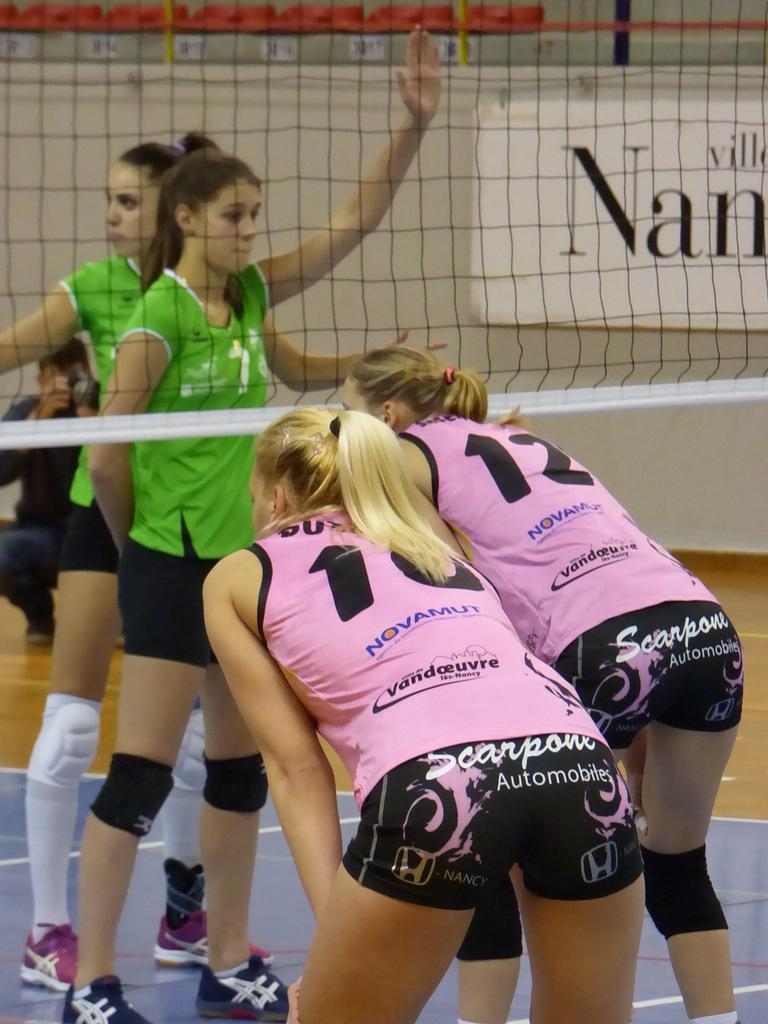<image>
Provide a brief description of the given image. Female volleyball players sponsored by Scarpone Automobiles Company. 